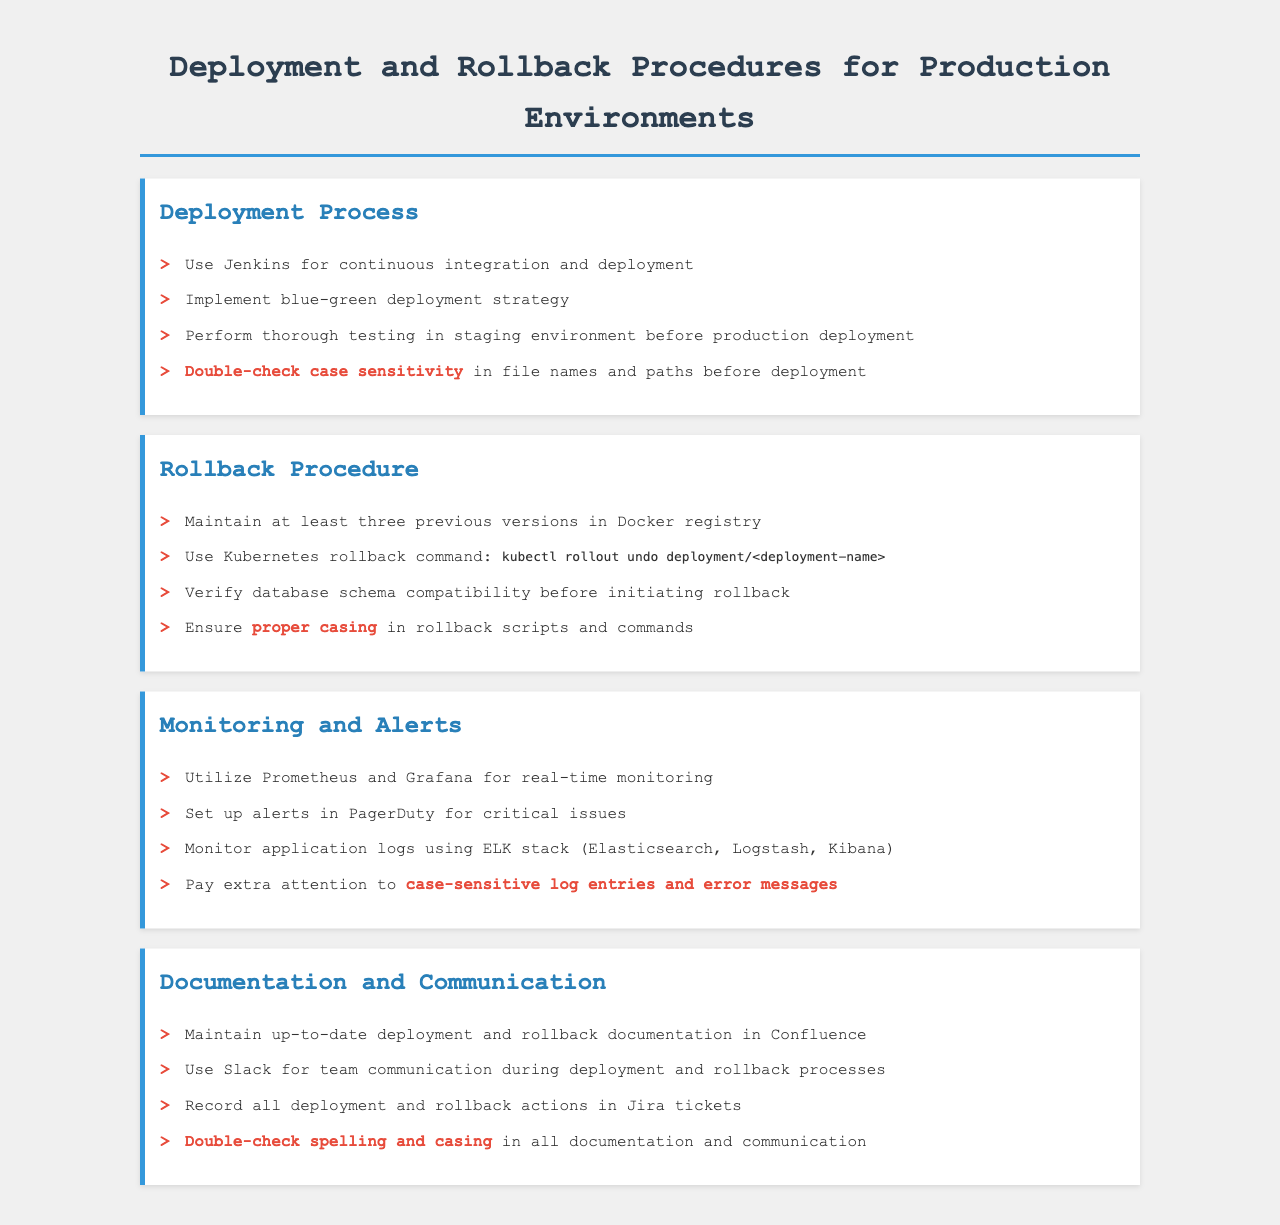What tool is used for continuous integration and deployment? The document specifies Jenkins as the tool for continuous integration and deployment.
Answer: Jenkins What strategy is implemented for deployment? The document mentions the blue-green deployment strategy as the method chosen for deployment.
Answer: blue-green deployment How many previous versions should be maintained in the Docker registry? According to the document, at least three previous versions should be maintained in the Docker registry.
Answer: three What command is used for rollback in Kubernetes? The rollback command specified in the document is "kubectl rollout undo deployment/<deployment-name>".
Answer: kubectl rollout undo deployment/<deployment-name> What monitoring tools are mentioned in the document? The document states that Prometheus and Grafana are utilized for real-time monitoring.
Answer: Prometheus and Grafana What platform is recommended for maintaining deployment documentation? The document advises using Confluence for maintaining up-to-date deployment and rollback documentation.
Answer: Confluence Why is it important to double-check case sensitivity? The document highlights that double-checking case sensitivity helps avoid errors in file names, paths, and scripts, specifically in deployment and rollback procedures.
Answer: avoid errors Which communication tool is suggested for team interaction? Slack is recommended in the document for team communication during deployment and rollback processes.
Answer: Slack What should be monitored closely according to the document? The document suggests paying extra attention to case-sensitive log entries and error messages in the monitoring process.
Answer: case-sensitive log entries and error messages 